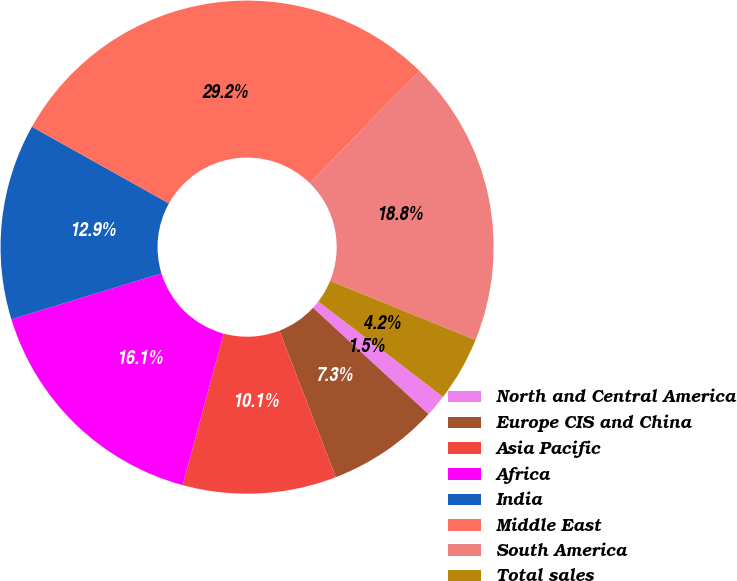<chart> <loc_0><loc_0><loc_500><loc_500><pie_chart><fcel>North and Central America<fcel>Europe CIS and China<fcel>Asia Pacific<fcel>Africa<fcel>India<fcel>Middle East<fcel>South America<fcel>Total sales<nl><fcel>1.46%<fcel>7.3%<fcel>10.07%<fcel>16.06%<fcel>12.85%<fcel>29.2%<fcel>18.83%<fcel>4.23%<nl></chart> 